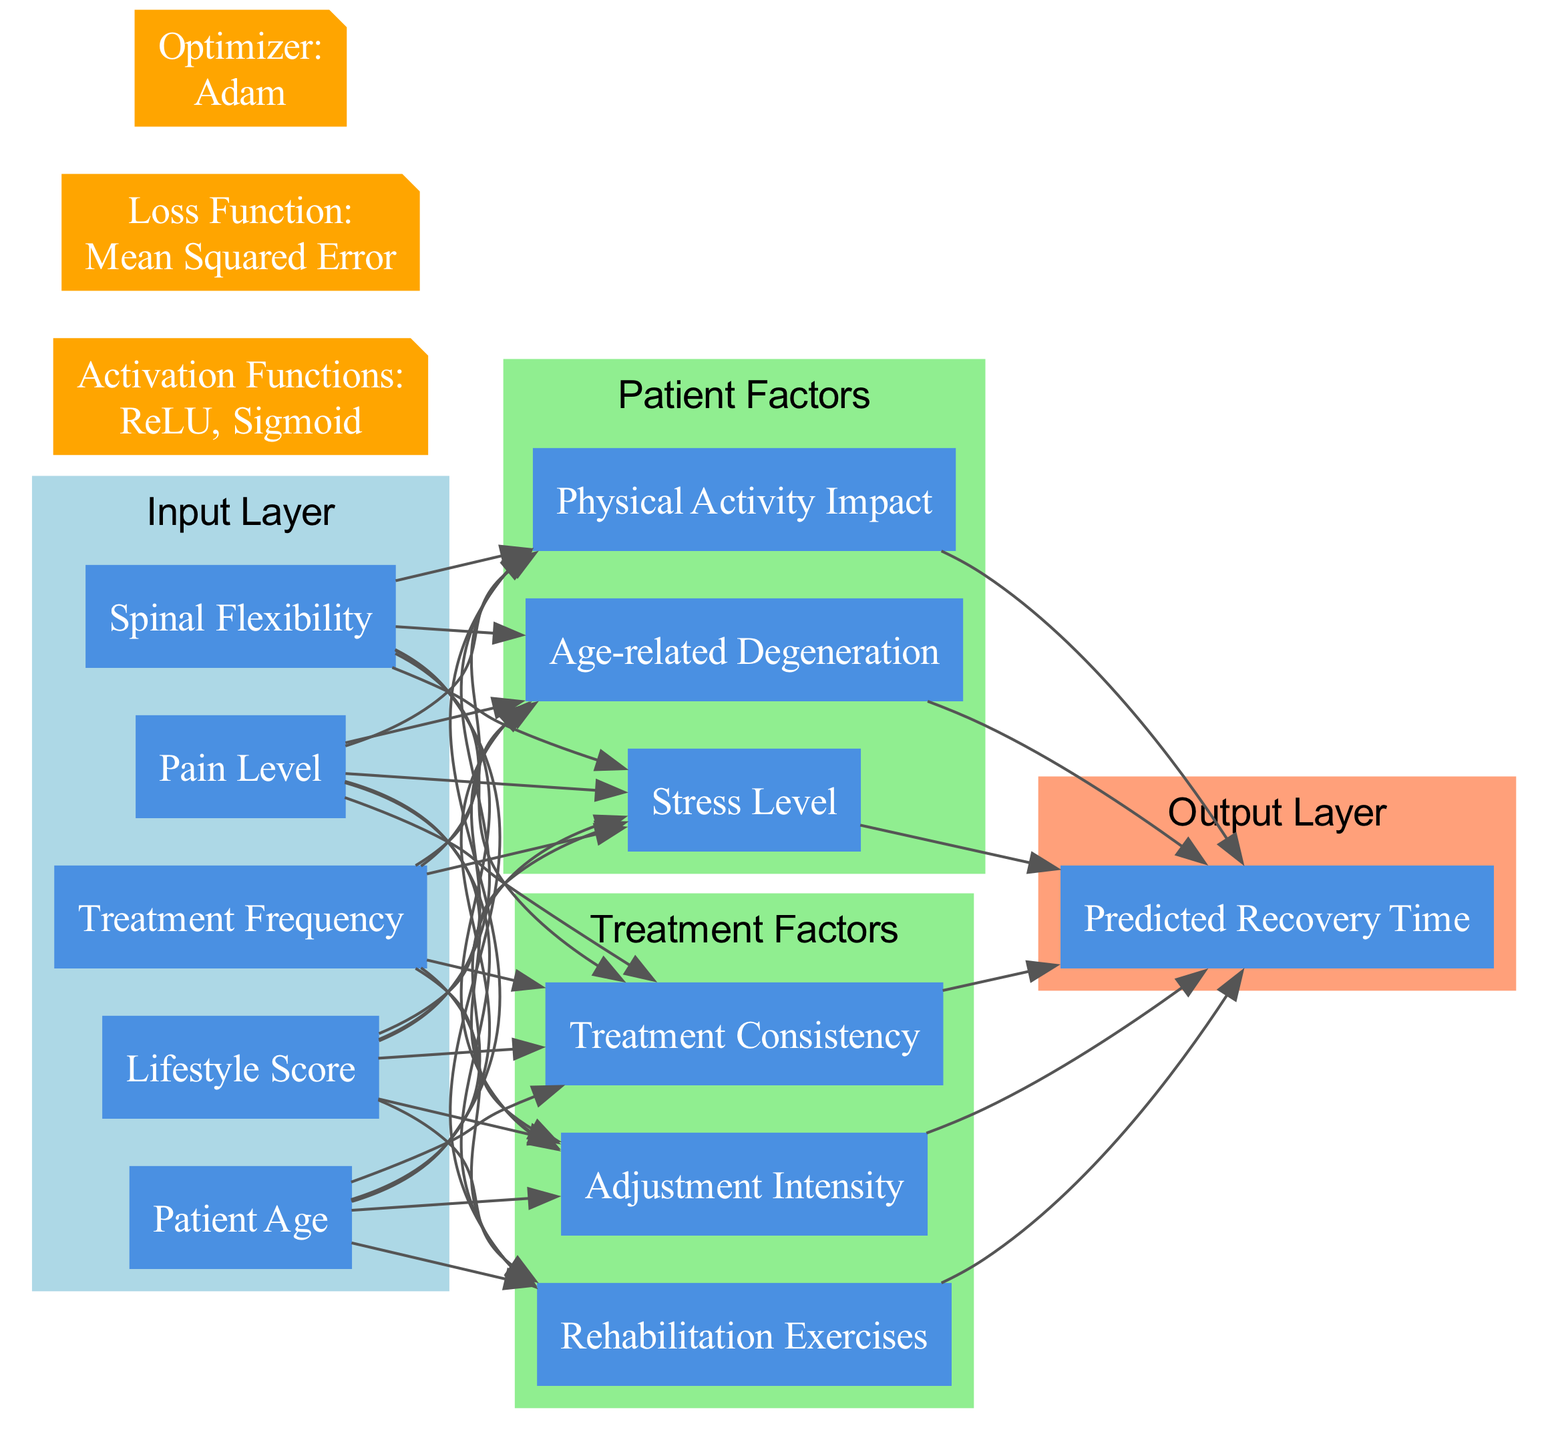What are the input nodes in this neural network? The input layer consists of five nodes: Patient Age, Lifestyle Score, Treatment Frequency, Pain Level, and Spinal Flexibility.
Answer: Patient Age, Lifestyle Score, Treatment Frequency, Pain Level, Spinal Flexibility How many hidden layers are present in the diagram? There are two hidden layers named Patient Factors and Treatment Factors. Each layer contains multiple nodes.
Answer: 2 Which activation function is specified in this diagram? The activation functions specified in the diagram are ReLU and Sigmoid, which are used for different nodes in the network.
Answer: ReLU, Sigmoid What is the loss function used in this model? The loss function defined in the diagram is Mean Squared Error, which is a common choice for regression problems.
Answer: Mean Squared Error Which node connects to the output layer? The nodes from both hidden layers (Patient Factors and Treatment Factors) connect to the output layer node, which is Predicted Recovery Time.
Answer: Predicted Recovery Time What connections exist between input and hidden layers? Each input node connects to the nodes in both hidden layers: Patient Factors and Treatment Factors, indicating their influence on prediction.
Answer: Patient Factors, Treatment Factors How many nodes are in the Patient Factors hidden layer? The Patient Factors hidden layer contains three nodes: Age-related Degeneration, Physical Activity Impact, and Stress Level.
Answer: 3 What optimizer is utilized in this neural network? The diagram specifies that the Adam optimizer is used for updating the weights during training.
Answer: Adam How many nodes are in the Treatment Factors hidden layer? The Treatment Factors hidden layer consists of three nodes: Adjustment Intensity, Treatment Consistency, and Rehabilitation Exercises.
Answer: 3 